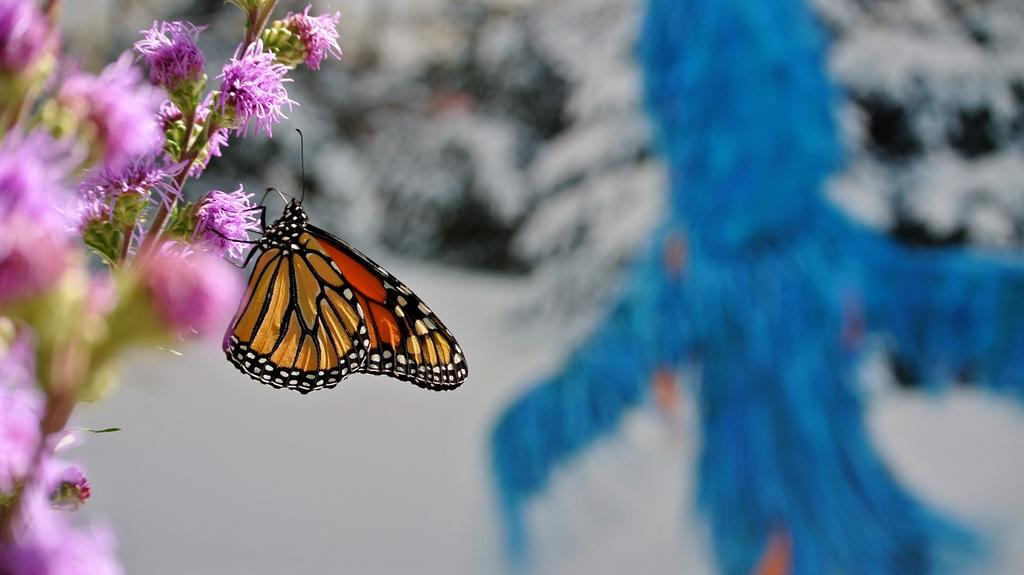What type of plant is visible in the image? There is a plant with flowers in the image. Are there any animals present in the image? Yes, there is a butterfly on one of the flowers. Can you describe the background of the image? The background of the image is blurred. Can you tell me how many men are walking along the seashore in the image? There are no men or seashore present in the image; it features a plant with flowers and a butterfly. 